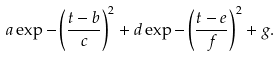Convert formula to latex. <formula><loc_0><loc_0><loc_500><loc_500>a \exp - \left ( \frac { t - b } { c } \right ) ^ { 2 } + d \exp - \left ( \frac { t - e } { f } \right ) ^ { 2 } + g .</formula> 